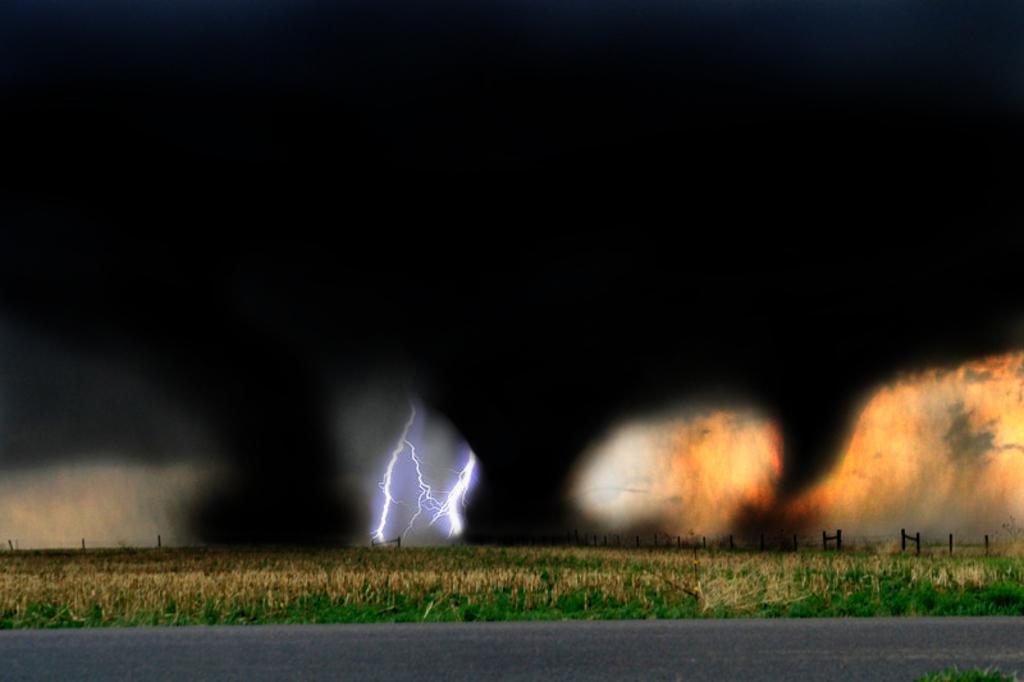In one or two sentences, can you explain what this image depicts? We can see road and grass. We can see fire and sparkle. In the background it is dark. 